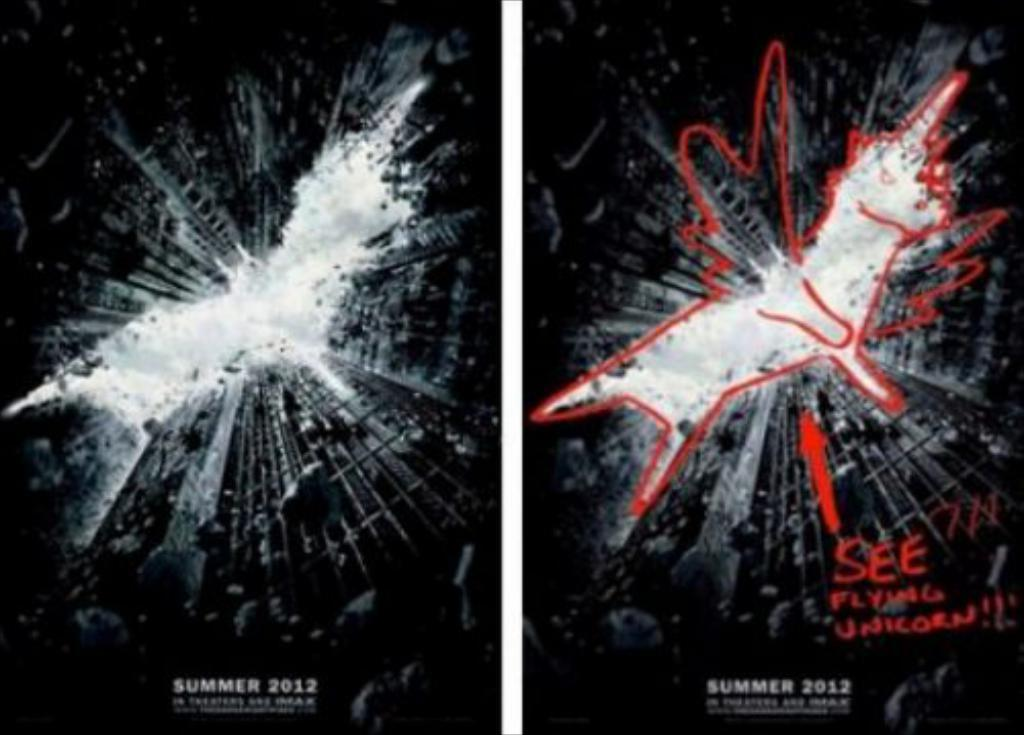<image>
Render a clear and concise summary of the photo. A batman movie poster has a sketch of a flying unicorn drawn on it. 